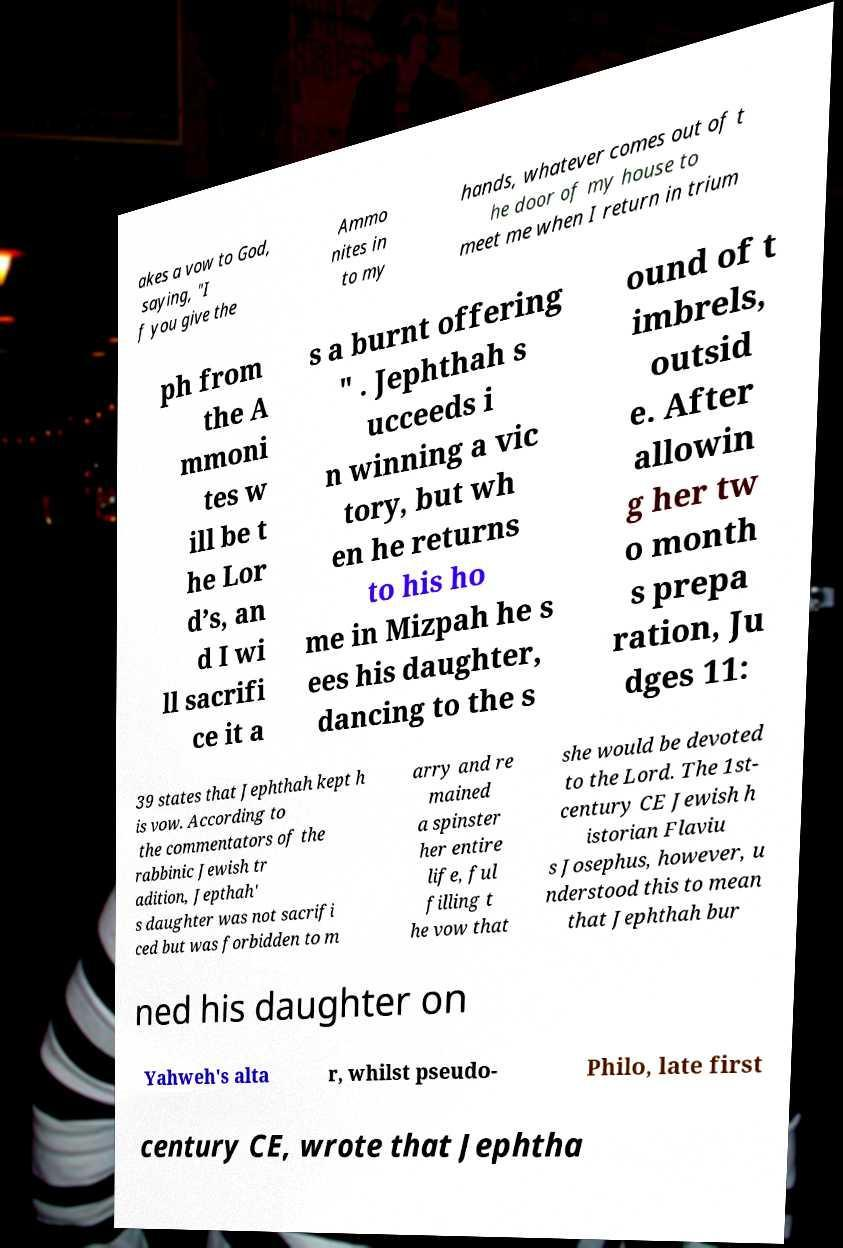Could you extract and type out the text from this image? akes a vow to God, saying, "I f you give the Ammo nites in to my hands, whatever comes out of t he door of my house to meet me when I return in trium ph from the A mmoni tes w ill be t he Lor d’s, an d I wi ll sacrifi ce it a s a burnt offering " . Jephthah s ucceeds i n winning a vic tory, but wh en he returns to his ho me in Mizpah he s ees his daughter, dancing to the s ound of t imbrels, outsid e. After allowin g her tw o month s prepa ration, Ju dges 11: 39 states that Jephthah kept h is vow. According to the commentators of the rabbinic Jewish tr adition, Jepthah' s daughter was not sacrifi ced but was forbidden to m arry and re mained a spinster her entire life, ful filling t he vow that she would be devoted to the Lord. The 1st- century CE Jewish h istorian Flaviu s Josephus, however, u nderstood this to mean that Jephthah bur ned his daughter on Yahweh's alta r, whilst pseudo- Philo, late first century CE, wrote that Jephtha 